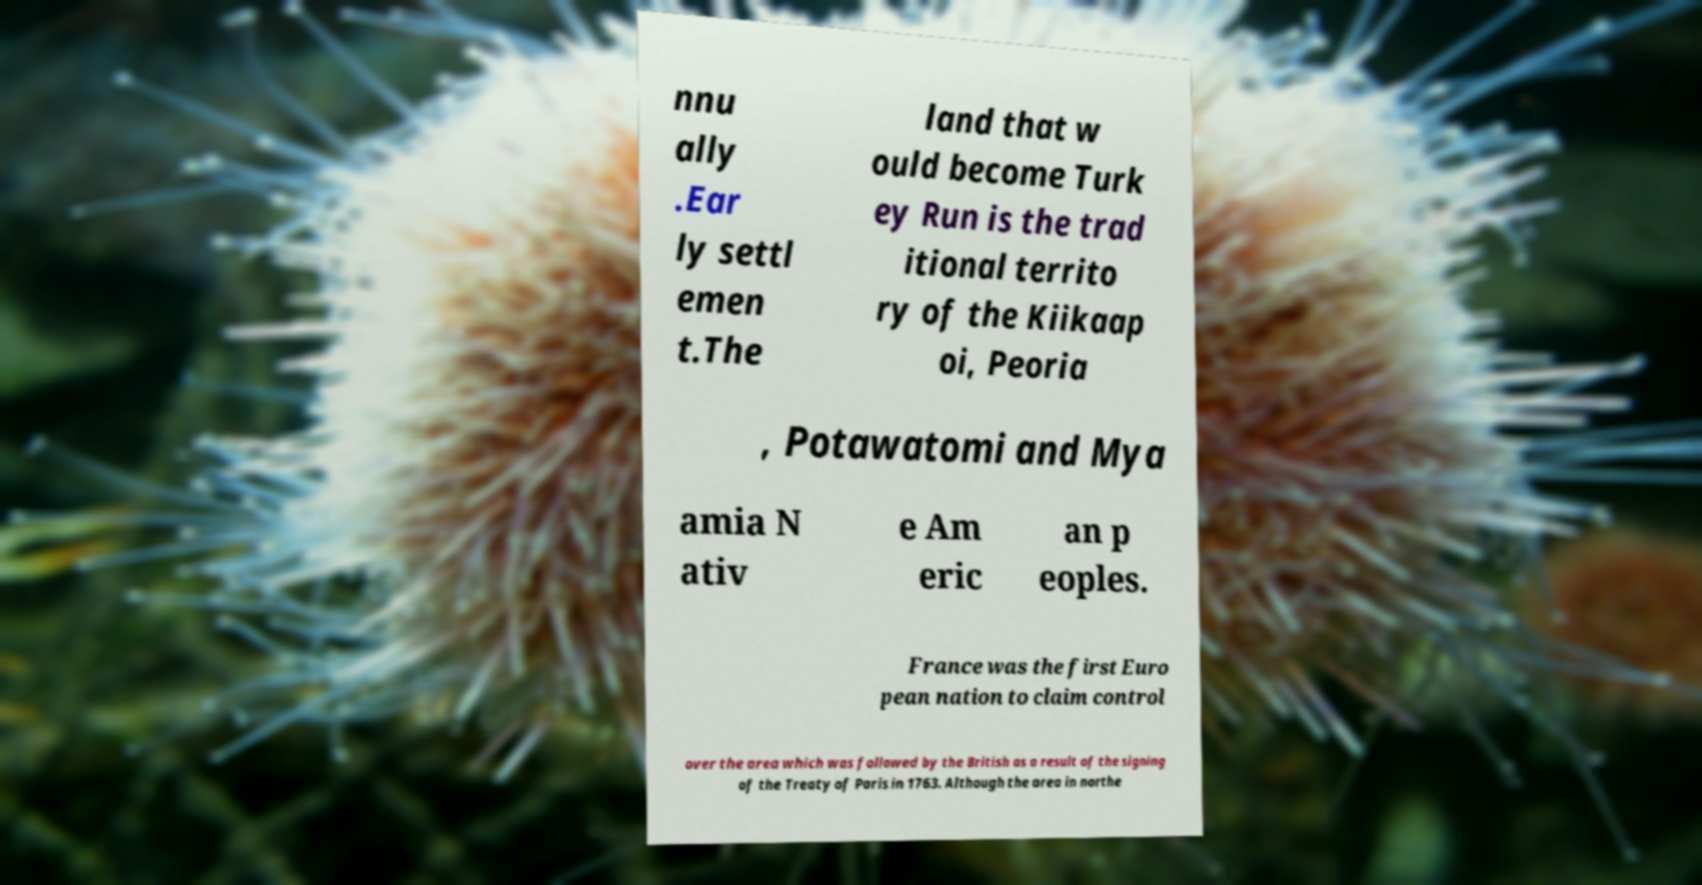Can you read and provide the text displayed in the image?This photo seems to have some interesting text. Can you extract and type it out for me? nnu ally .Ear ly settl emen t.The land that w ould become Turk ey Run is the trad itional territo ry of the Kiikaap oi, Peoria , Potawatomi and Mya amia N ativ e Am eric an p eoples. France was the first Euro pean nation to claim control over the area which was followed by the British as a result of the signing of the Treaty of Paris in 1763. Although the area in northe 